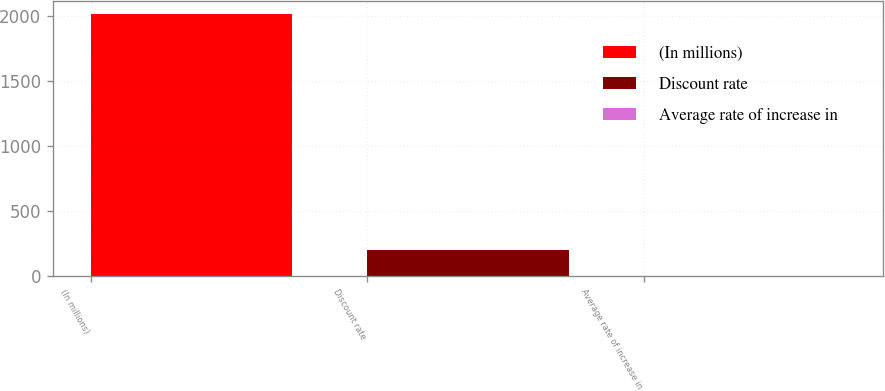Convert chart. <chart><loc_0><loc_0><loc_500><loc_500><bar_chart><fcel>(In millions)<fcel>Discount rate<fcel>Average rate of increase in<nl><fcel>2012<fcel>203.85<fcel>2.94<nl></chart> 